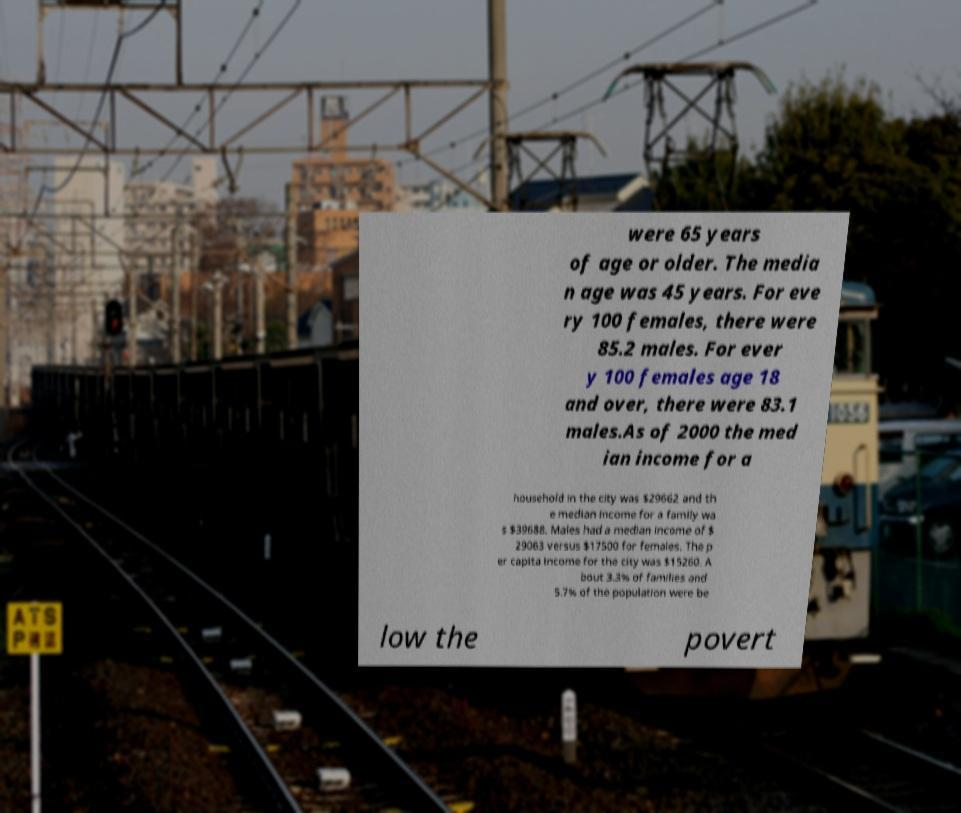Why might someone display these statistics in such a public and perhaps unusual setting? Displaying socioeconomic statistics in a public setting like a train station could be a method of raising awareness or prompting discussion about these issues among the commuters and the general public. It serves as a direct reminder of the city's economic and social conditions, possibly aiming to engage community members in civic discussions or actions. 